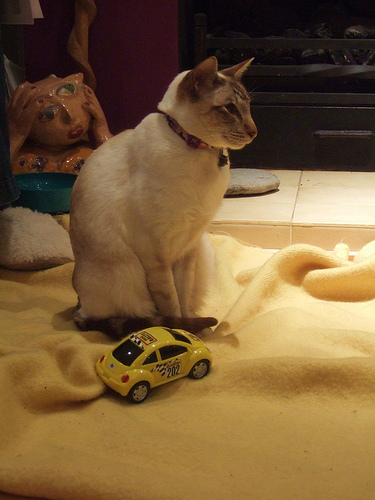What is the small object next to the cat, and what does it signify? Next to the cat is a small, yellow toy car, which could signify that the cat might enjoy playing with toys or live in a household with children who own the toy. It adds a playful element to the scene. 